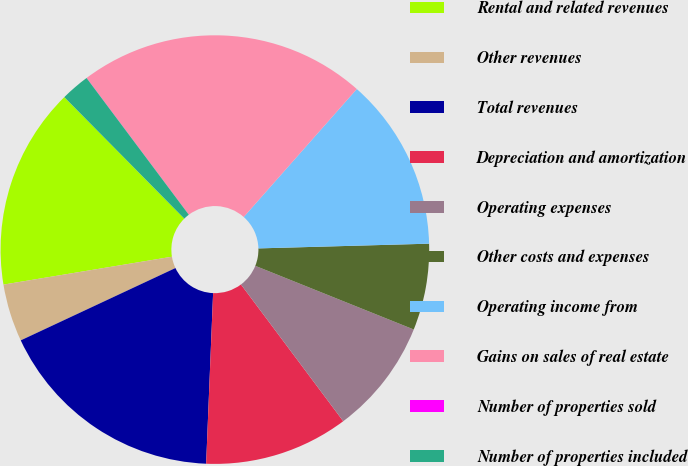<chart> <loc_0><loc_0><loc_500><loc_500><pie_chart><fcel>Rental and related revenues<fcel>Other revenues<fcel>Total revenues<fcel>Depreciation and amortization<fcel>Operating expenses<fcel>Other costs and expenses<fcel>Operating income from<fcel>Gains on sales of real estate<fcel>Number of properties sold<fcel>Number of properties included<nl><fcel>15.21%<fcel>4.35%<fcel>17.39%<fcel>10.87%<fcel>8.7%<fcel>6.52%<fcel>13.04%<fcel>21.73%<fcel>0.01%<fcel>2.18%<nl></chart> 